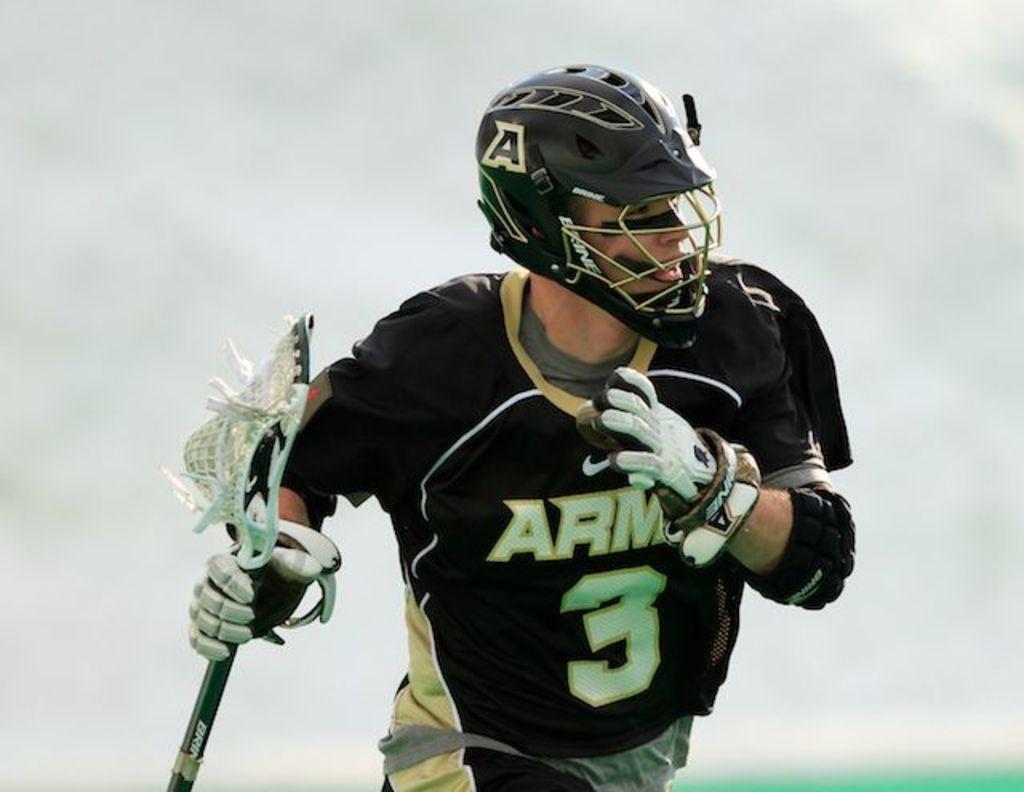In one or two sentences, can you explain what this image depicts? In this picture there is a person holding lacrosse stick and wore helmet and gloves. In the background of the image it is white. 